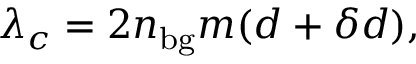Convert formula to latex. <formula><loc_0><loc_0><loc_500><loc_500>\lambda _ { c } = 2 n _ { b g } m ( d + \delta d ) ,</formula> 